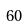<formula> <loc_0><loc_0><loc_500><loc_500>6 0</formula> 